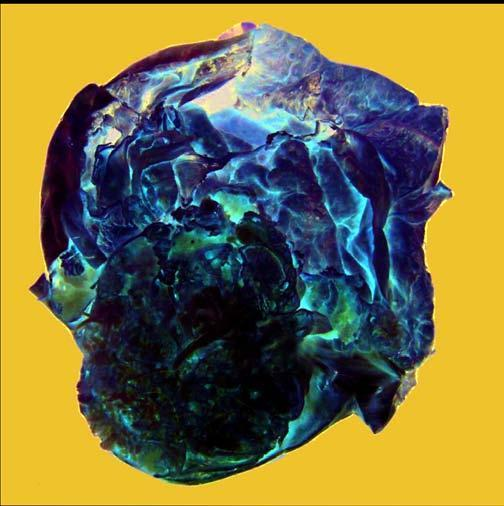does icroscopic appearance of normal testis show presence of loculi containing gelatinous mucoid material?
Answer the question using a single word or phrase. No 